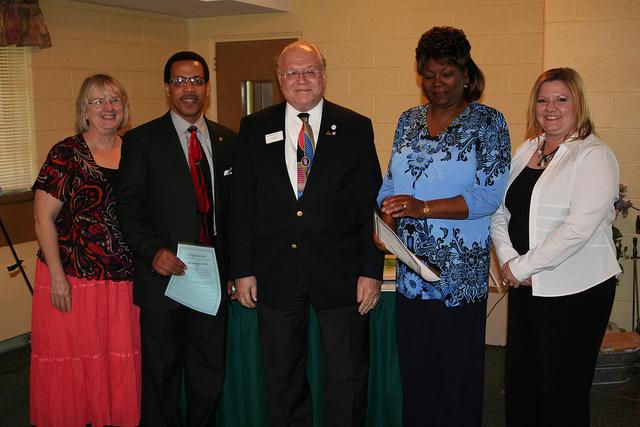Is someone talking to the people?
Short answer required. No. What color is the woman's dress?
Concise answer only. Pink. What color is the woman on the lefts dress?
Answer briefly. Red. What are they doing with the white items in their hands?
Answer briefly. Holding. How many men are in this picture?
Be succinct. 2. Were these 'people' in the military?
Be succinct. No. How many women are in the picture?
Quick response, please. 3. What country are they from?
Short answer required. America. How many white person do you see?
Answer briefly. 3. What is the gender of majority in this room?
Give a very brief answer. Female. Why is the man in the middle wearing a tie?
Write a very short answer. Yes. Is all the people the same race?
Answer briefly. No. Does this appear to be a family?
Concise answer only. No. What is the one man holding in his right hand?
Answer briefly. Paper. What is the lady in the print dress doing with her arms?
Short answer required. Nothing. 